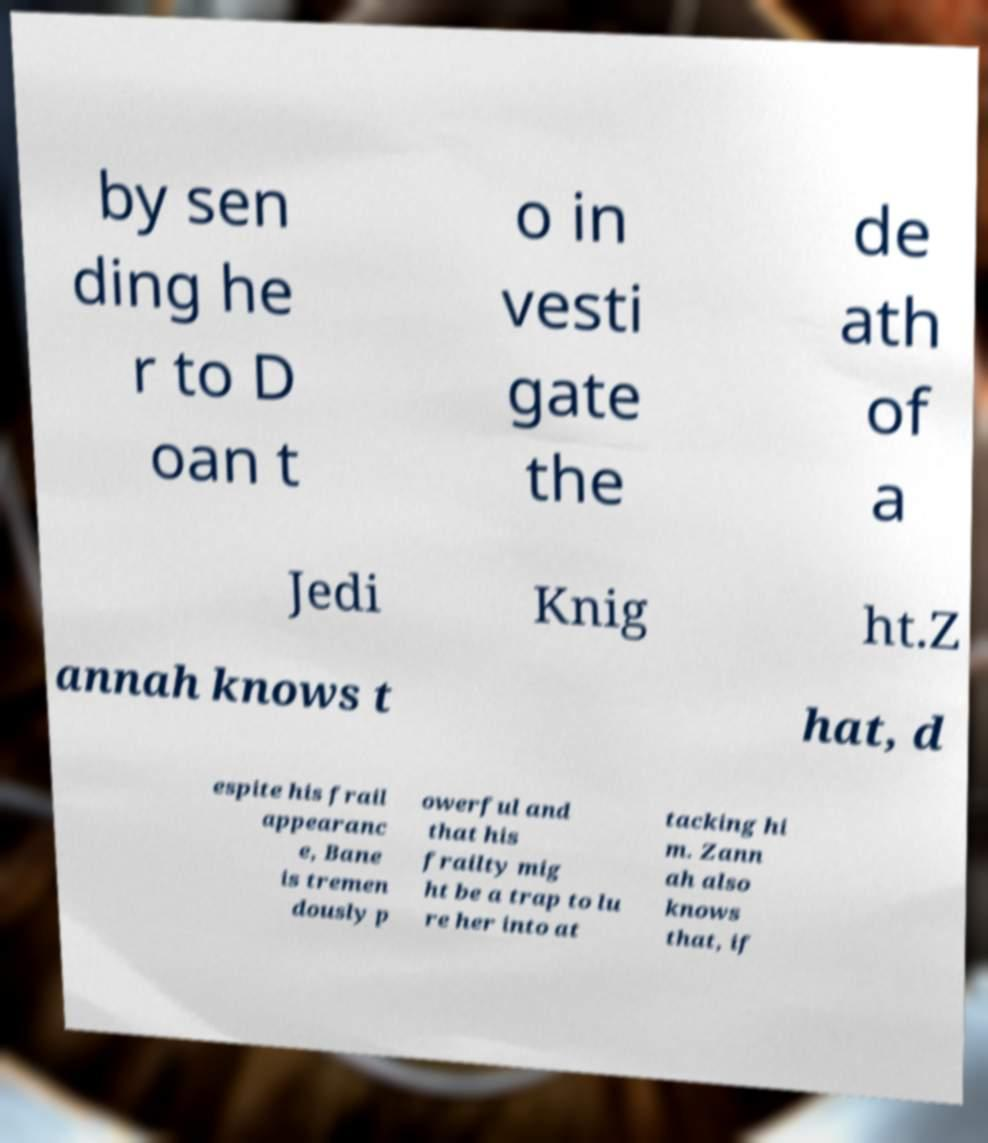There's text embedded in this image that I need extracted. Can you transcribe it verbatim? by sen ding he r to D oan t o in vesti gate the de ath of a Jedi Knig ht.Z annah knows t hat, d espite his frail appearanc e, Bane is tremen dously p owerful and that his frailty mig ht be a trap to lu re her into at tacking hi m. Zann ah also knows that, if 